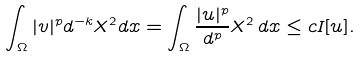Convert formula to latex. <formula><loc_0><loc_0><loc_500><loc_500>\int _ { \Omega } | v | ^ { p } d ^ { - k } X ^ { 2 } d x = \int _ { \Omega } \frac { | u | ^ { p } } { d ^ { p } } X ^ { 2 } \, d x \leq c I [ u ] .</formula> 